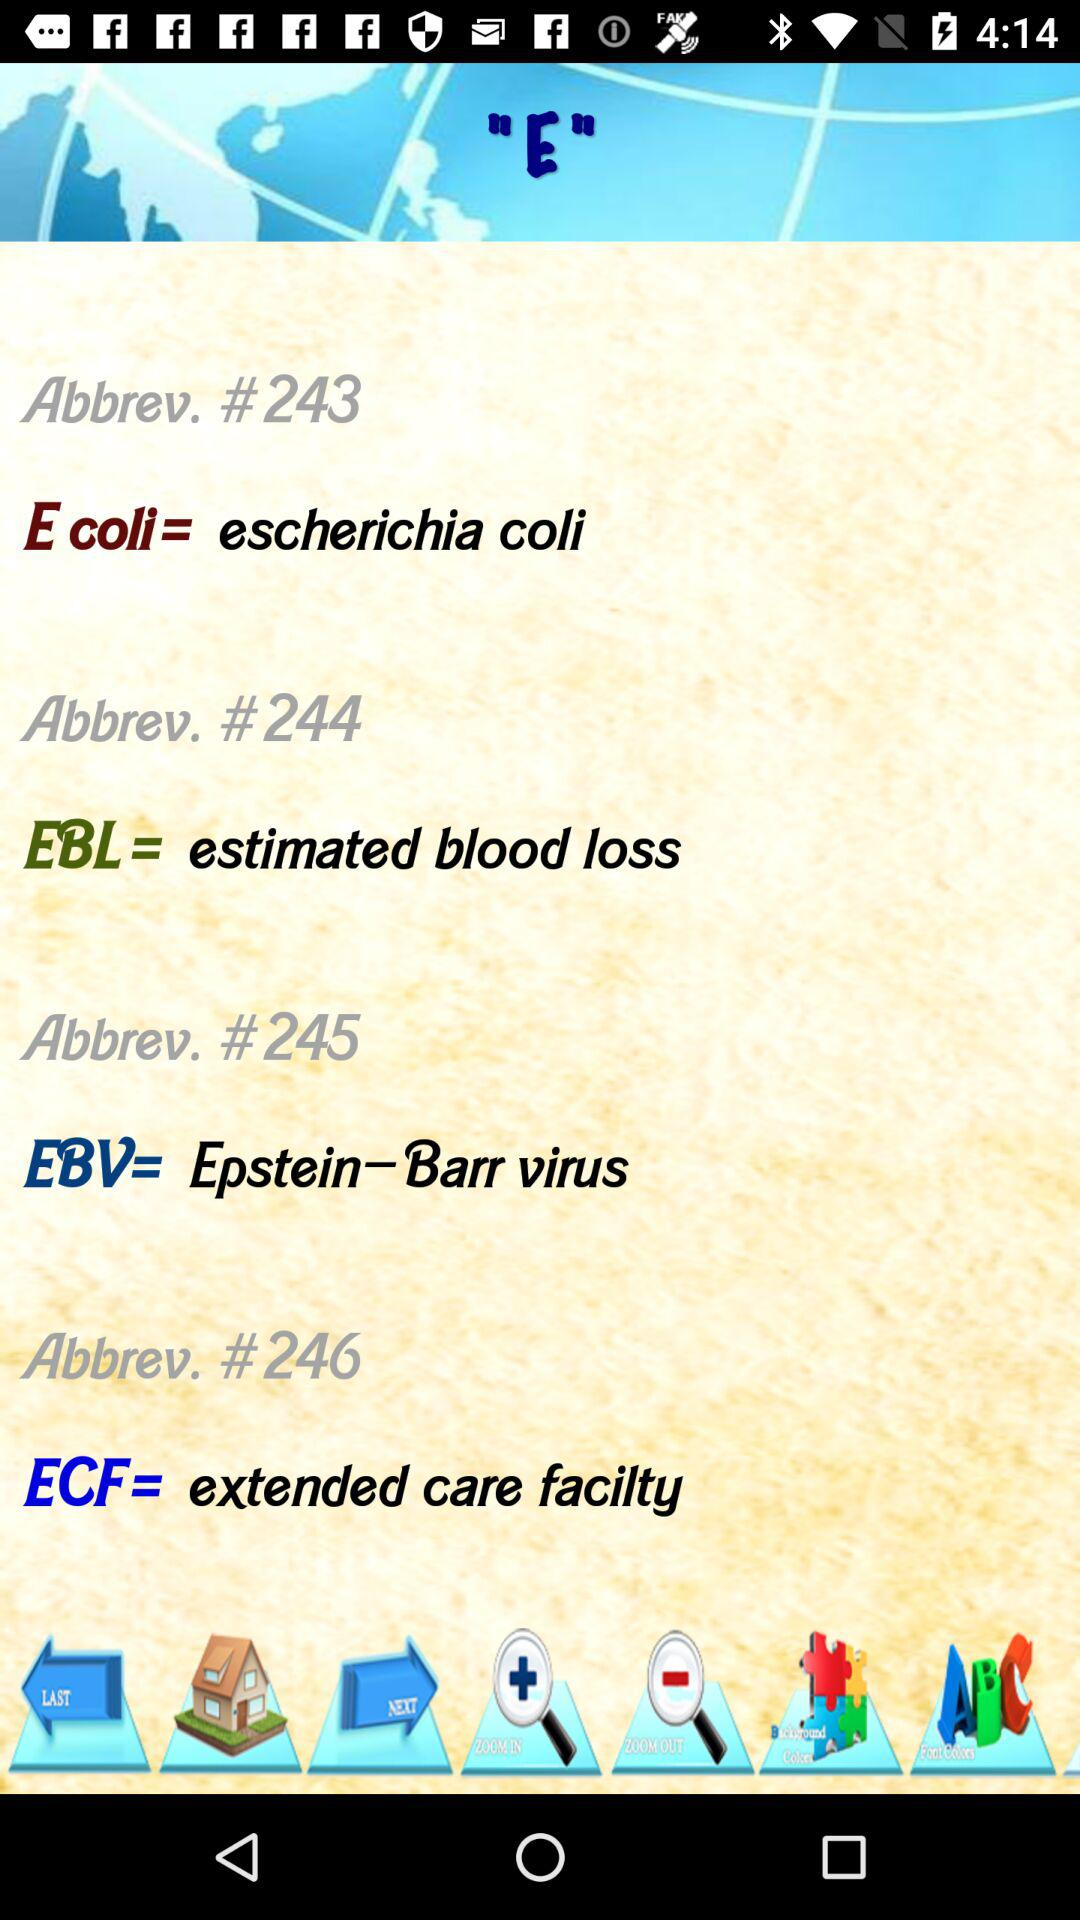What is the full form of EBL? The full form of EBL is Estimated Blood Loss. 